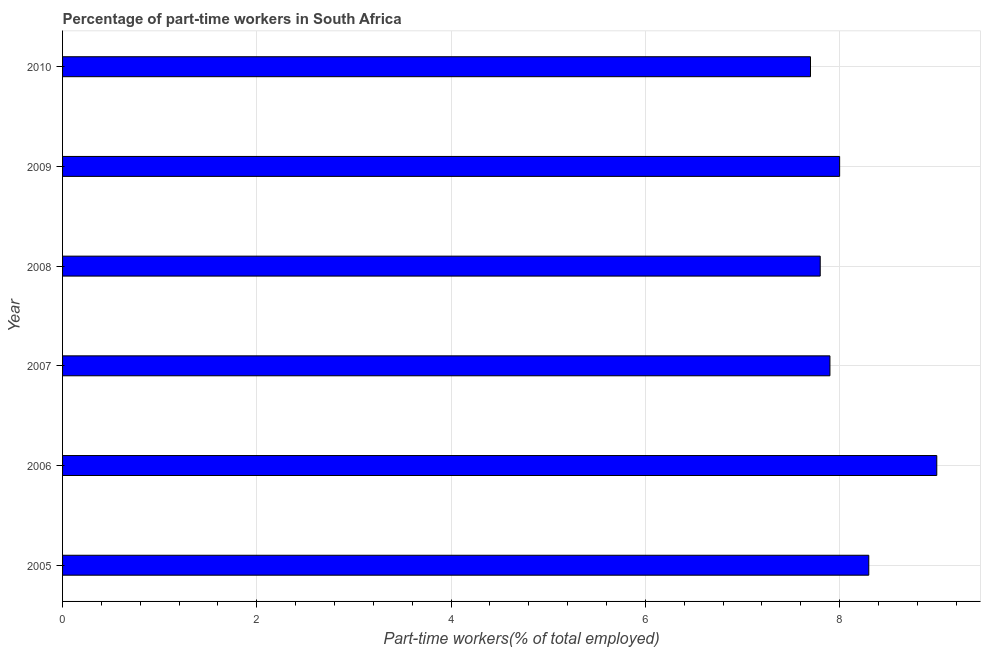Does the graph contain grids?
Ensure brevity in your answer.  Yes. What is the title of the graph?
Keep it short and to the point. Percentage of part-time workers in South Africa. What is the label or title of the X-axis?
Keep it short and to the point. Part-time workers(% of total employed). What is the label or title of the Y-axis?
Give a very brief answer. Year. What is the percentage of part-time workers in 2010?
Provide a succinct answer. 7.7. Across all years, what is the minimum percentage of part-time workers?
Provide a short and direct response. 7.7. What is the sum of the percentage of part-time workers?
Give a very brief answer. 48.7. What is the average percentage of part-time workers per year?
Your answer should be compact. 8.12. What is the median percentage of part-time workers?
Your answer should be compact. 7.95. Do a majority of the years between 2009 and 2007 (inclusive) have percentage of part-time workers greater than 4.8 %?
Keep it short and to the point. Yes. What is the ratio of the percentage of part-time workers in 2006 to that in 2010?
Offer a very short reply. 1.17. Is the percentage of part-time workers in 2007 less than that in 2009?
Ensure brevity in your answer.  Yes. What is the difference between the highest and the second highest percentage of part-time workers?
Make the answer very short. 0.7. What is the difference between the highest and the lowest percentage of part-time workers?
Your answer should be very brief. 1.3. In how many years, is the percentage of part-time workers greater than the average percentage of part-time workers taken over all years?
Keep it short and to the point. 2. How many bars are there?
Provide a succinct answer. 6. How many years are there in the graph?
Offer a terse response. 6. What is the Part-time workers(% of total employed) of 2005?
Your answer should be compact. 8.3. What is the Part-time workers(% of total employed) in 2007?
Your answer should be very brief. 7.9. What is the Part-time workers(% of total employed) of 2008?
Offer a very short reply. 7.8. What is the Part-time workers(% of total employed) of 2010?
Offer a terse response. 7.7. What is the difference between the Part-time workers(% of total employed) in 2005 and 2008?
Ensure brevity in your answer.  0.5. What is the difference between the Part-time workers(% of total employed) in 2005 and 2010?
Your response must be concise. 0.6. What is the difference between the Part-time workers(% of total employed) in 2006 and 2007?
Give a very brief answer. 1.1. What is the difference between the Part-time workers(% of total employed) in 2006 and 2009?
Offer a terse response. 1. What is the difference between the Part-time workers(% of total employed) in 2006 and 2010?
Offer a very short reply. 1.3. What is the difference between the Part-time workers(% of total employed) in 2007 and 2009?
Your answer should be very brief. -0.1. What is the difference between the Part-time workers(% of total employed) in 2007 and 2010?
Keep it short and to the point. 0.2. What is the difference between the Part-time workers(% of total employed) in 2008 and 2009?
Your answer should be compact. -0.2. What is the difference between the Part-time workers(% of total employed) in 2009 and 2010?
Keep it short and to the point. 0.3. What is the ratio of the Part-time workers(% of total employed) in 2005 to that in 2006?
Make the answer very short. 0.92. What is the ratio of the Part-time workers(% of total employed) in 2005 to that in 2007?
Keep it short and to the point. 1.05. What is the ratio of the Part-time workers(% of total employed) in 2005 to that in 2008?
Offer a very short reply. 1.06. What is the ratio of the Part-time workers(% of total employed) in 2005 to that in 2009?
Give a very brief answer. 1.04. What is the ratio of the Part-time workers(% of total employed) in 2005 to that in 2010?
Give a very brief answer. 1.08. What is the ratio of the Part-time workers(% of total employed) in 2006 to that in 2007?
Make the answer very short. 1.14. What is the ratio of the Part-time workers(% of total employed) in 2006 to that in 2008?
Your answer should be compact. 1.15. What is the ratio of the Part-time workers(% of total employed) in 2006 to that in 2010?
Provide a short and direct response. 1.17. What is the ratio of the Part-time workers(% of total employed) in 2007 to that in 2008?
Give a very brief answer. 1.01. What is the ratio of the Part-time workers(% of total employed) in 2007 to that in 2010?
Give a very brief answer. 1.03. What is the ratio of the Part-time workers(% of total employed) in 2008 to that in 2009?
Offer a terse response. 0.97. What is the ratio of the Part-time workers(% of total employed) in 2009 to that in 2010?
Offer a very short reply. 1.04. 